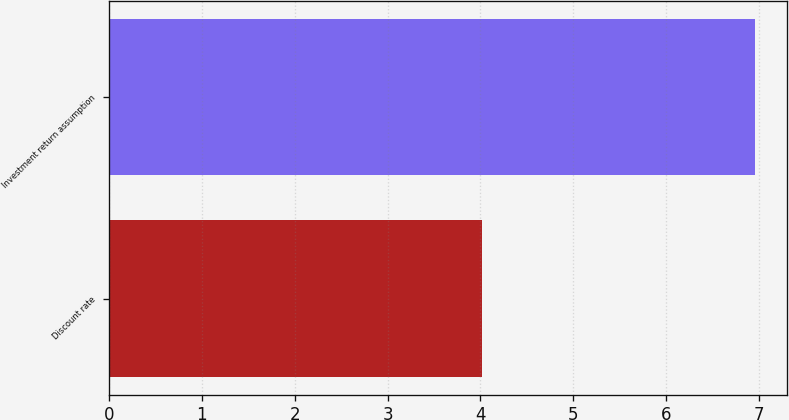Convert chart to OTSL. <chart><loc_0><loc_0><loc_500><loc_500><bar_chart><fcel>Discount rate<fcel>Investment return assumption<nl><fcel>4.02<fcel>6.95<nl></chart> 